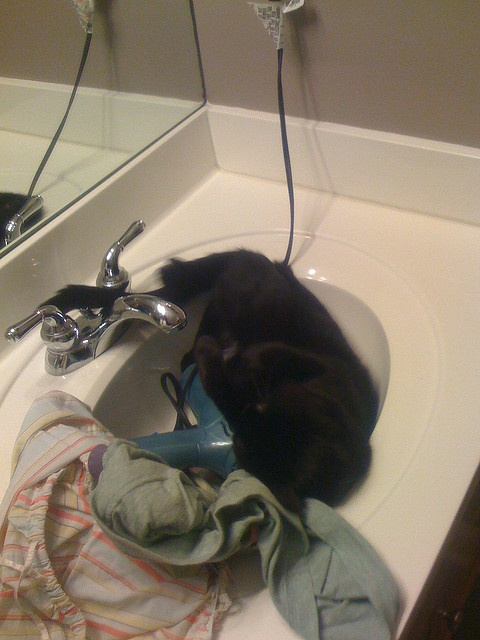Describe the objects in this image and their specific colors. I can see sink in olive, tan, and gray tones, cat in olive, black, and gray tones, and hair drier in olive, purple, black, gray, and darkblue tones in this image. 